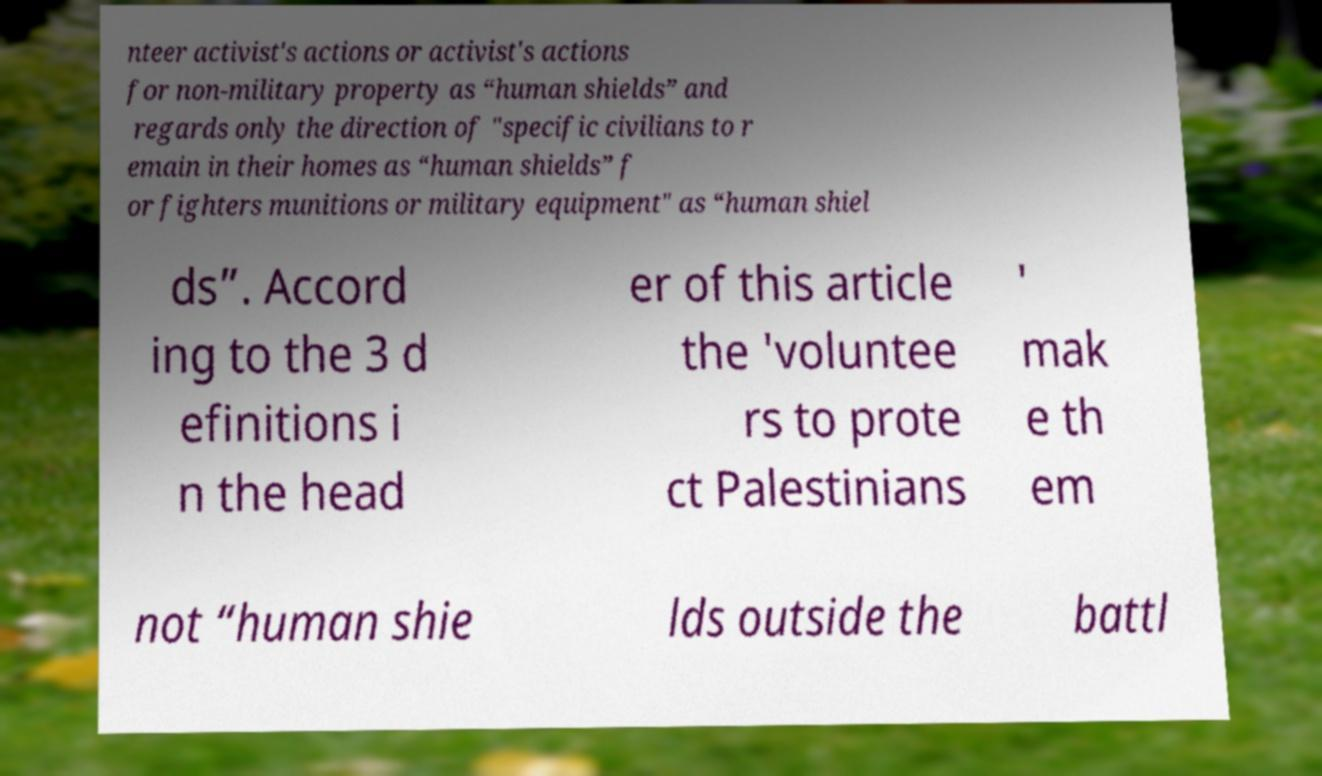There's text embedded in this image that I need extracted. Can you transcribe it verbatim? nteer activist's actions or activist's actions for non-military property as “human shields” and regards only the direction of "specific civilians to r emain in their homes as “human shields” f or fighters munitions or military equipment" as “human shiel ds”. Accord ing to the 3 d efinitions i n the head er of this article the 'voluntee rs to prote ct Palestinians ' mak e th em not “human shie lds outside the battl 